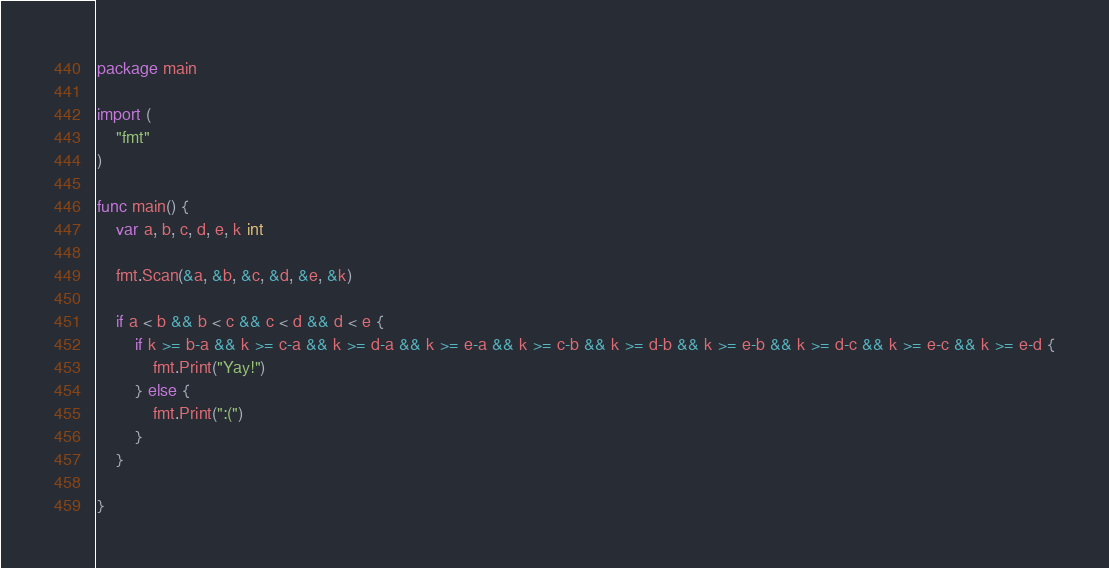<code> <loc_0><loc_0><loc_500><loc_500><_Go_>package main

import (
	"fmt"
)

func main() {
	var a, b, c, d, e, k int

	fmt.Scan(&a, &b, &c, &d, &e, &k)

	if a < b && b < c && c < d && d < e {
		if k >= b-a && k >= c-a && k >= d-a && k >= e-a && k >= c-b && k >= d-b && k >= e-b && k >= d-c && k >= e-c && k >= e-d {
			fmt.Print("Yay!")
		} else {
			fmt.Print(":(")
		}
	}

}
</code> 